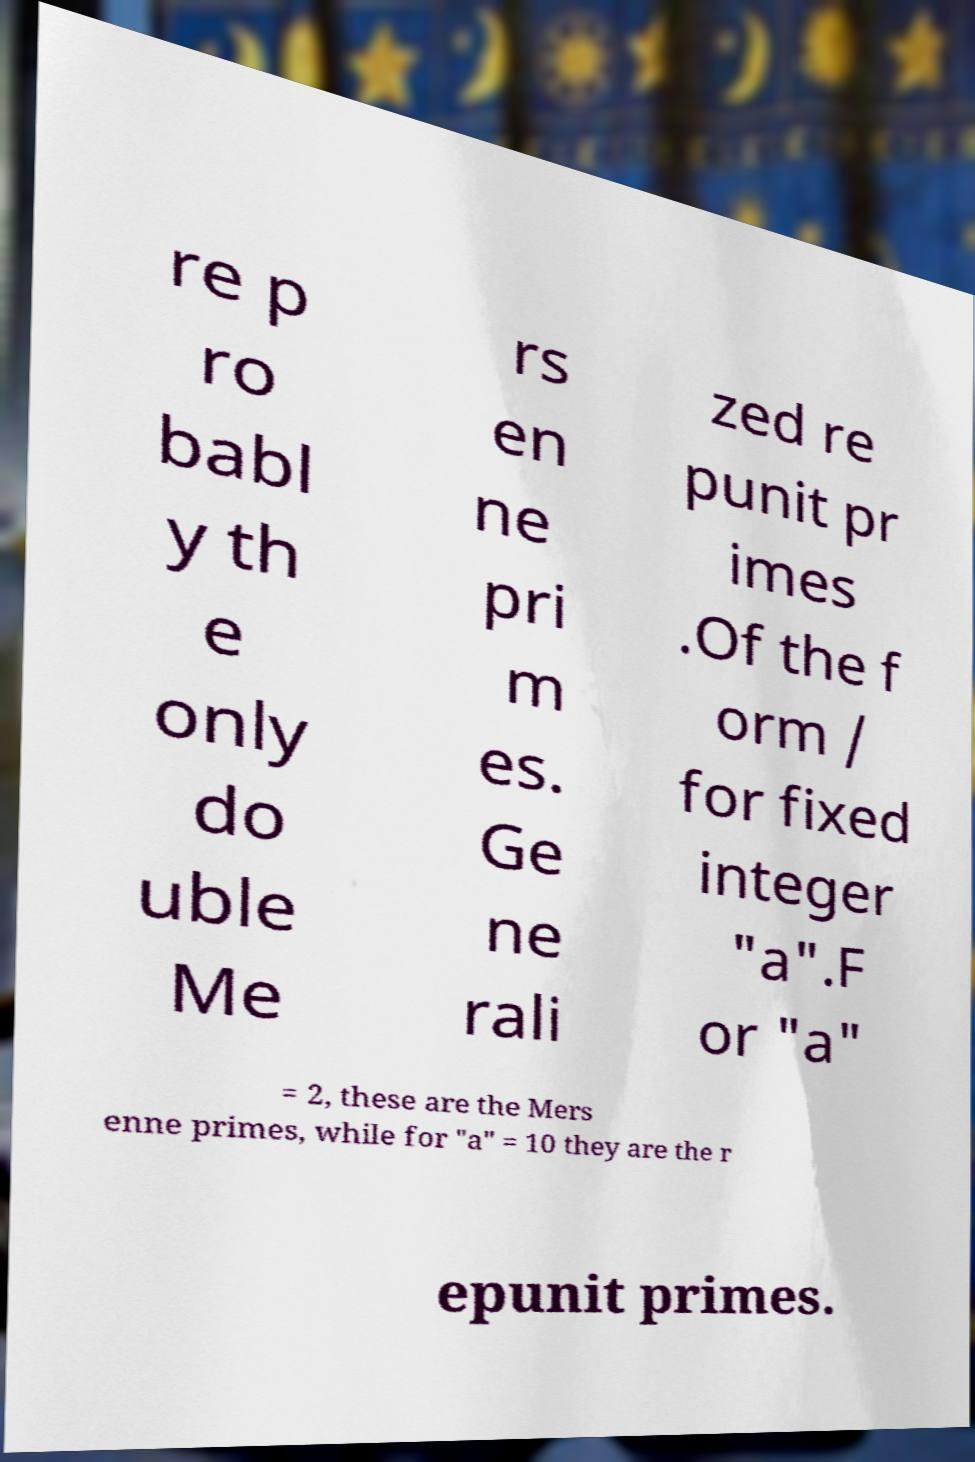For documentation purposes, I need the text within this image transcribed. Could you provide that? re p ro babl y th e only do uble Me rs en ne pri m es. Ge ne rali zed re punit pr imes .Of the f orm / for fixed integer "a".F or "a" = 2, these are the Mers enne primes, while for "a" = 10 they are the r epunit primes. 